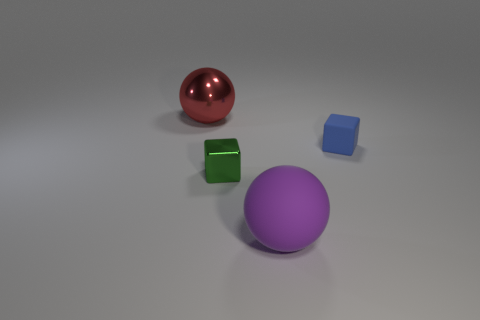There is a metallic object in front of the tiny thing right of the big sphere in front of the big metallic ball; how big is it?
Offer a very short reply. Small. How many other things are there of the same material as the large purple thing?
Your response must be concise. 1. There is a cube that is on the right side of the tiny green thing; what is its size?
Your answer should be compact. Small. What number of large balls are to the right of the big shiny object and left of the rubber ball?
Provide a short and direct response. 0. What material is the cube left of the large ball right of the big red ball?
Keep it short and to the point. Metal. There is another small object that is the same shape as the small matte object; what is it made of?
Your response must be concise. Metal. Are any shiny spheres visible?
Your response must be concise. Yes. What is the shape of the large purple thing that is the same material as the small blue thing?
Ensure brevity in your answer.  Sphere. What material is the green cube in front of the blue matte block?
Offer a terse response. Metal. Does the shiny thing that is right of the large metal object have the same color as the rubber sphere?
Offer a terse response. No. 